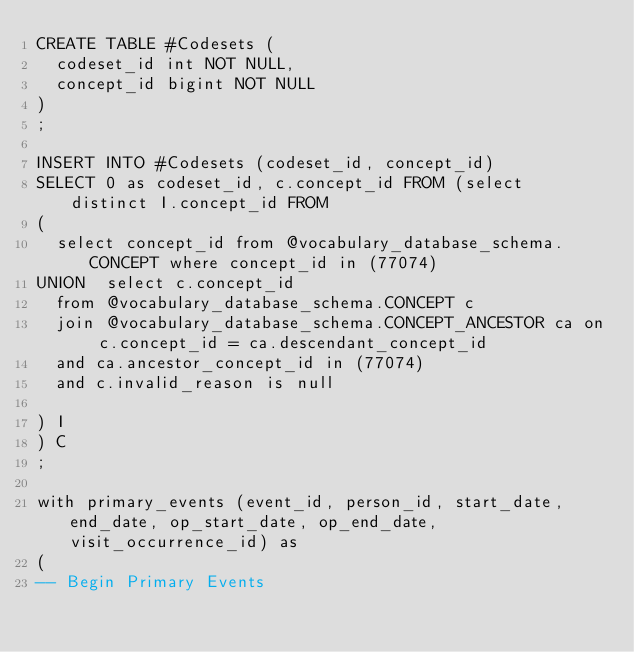Convert code to text. <code><loc_0><loc_0><loc_500><loc_500><_SQL_>CREATE TABLE #Codesets (
  codeset_id int NOT NULL,
  concept_id bigint NOT NULL
)
;

INSERT INTO #Codesets (codeset_id, concept_id)
SELECT 0 as codeset_id, c.concept_id FROM (select distinct I.concept_id FROM
( 
  select concept_id from @vocabulary_database_schema.CONCEPT where concept_id in (77074)
UNION  select c.concept_id
  from @vocabulary_database_schema.CONCEPT c
  join @vocabulary_database_schema.CONCEPT_ANCESTOR ca on c.concept_id = ca.descendant_concept_id
  and ca.ancestor_concept_id in (77074)
  and c.invalid_reason is null

) I
) C
;

with primary_events (event_id, person_id, start_date, end_date, op_start_date, op_end_date, visit_occurrence_id) as
(
-- Begin Primary Events</code> 